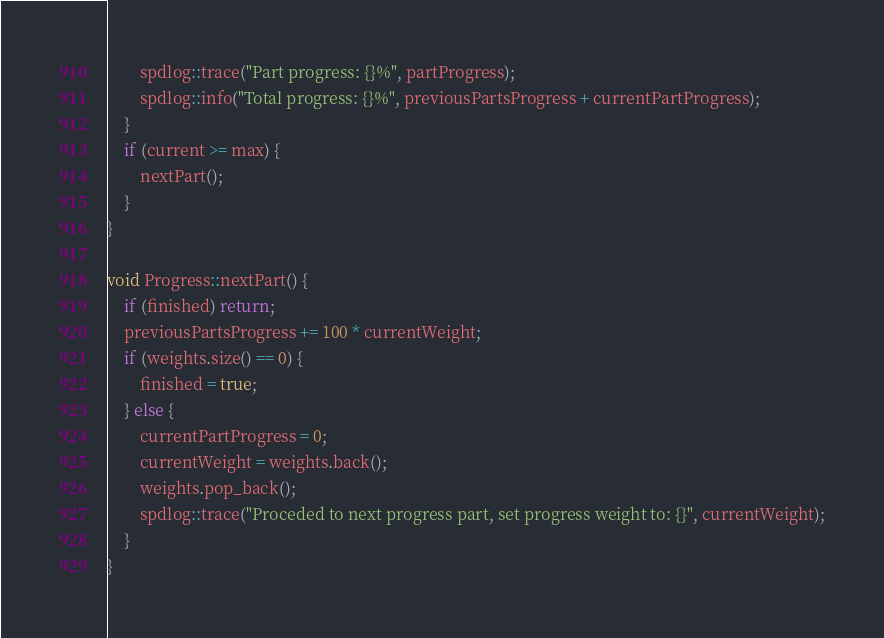Convert code to text. <code><loc_0><loc_0><loc_500><loc_500><_C++_>        spdlog::trace("Part progress: {}%", partProgress);
        spdlog::info("Total progress: {}%", previousPartsProgress + currentPartProgress);
    }
    if (current >= max) {
        nextPart();
    }
}

void Progress::nextPart() {
    if (finished) return;
    previousPartsProgress += 100 * currentWeight;
    if (weights.size() == 0) {
        finished = true;
    } else {
        currentPartProgress = 0;
        currentWeight = weights.back();
        weights.pop_back();
        spdlog::trace("Proceded to next progress part, set progress weight to: {}", currentWeight);
    }
}
</code> 